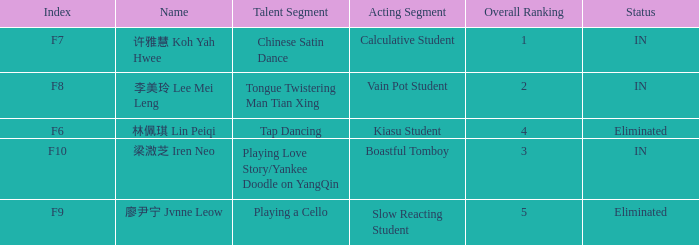Write the full table. {'header': ['Index', 'Name', 'Talent Segment', 'Acting Segment', 'Overall Ranking', 'Status'], 'rows': [['F7', '许雅慧 Koh Yah Hwee', 'Chinese Satin Dance', 'Calculative Student', '1', 'IN'], ['F8', '李美玲 Lee Mei Leng', 'Tongue Twistering Man Tian Xing', 'Vain Pot Student', '2', 'IN'], ['F6', '林佩琪 Lin Peiqi', 'Tap Dancing', 'Kiasu Student', '4', 'Eliminated'], ['F10', '梁溦芝 Iren Neo', 'Playing Love Story/Yankee Doodle on YangQin', 'Boastful Tomboy', '3', 'IN'], ['F9', '廖尹宁 Jvnne Leow', 'Playing a Cello', 'Slow Reacting Student', '5', 'Eliminated']]} What's the total number of overall rankings of 廖尹宁 jvnne leow's events that are eliminated? 1.0. 